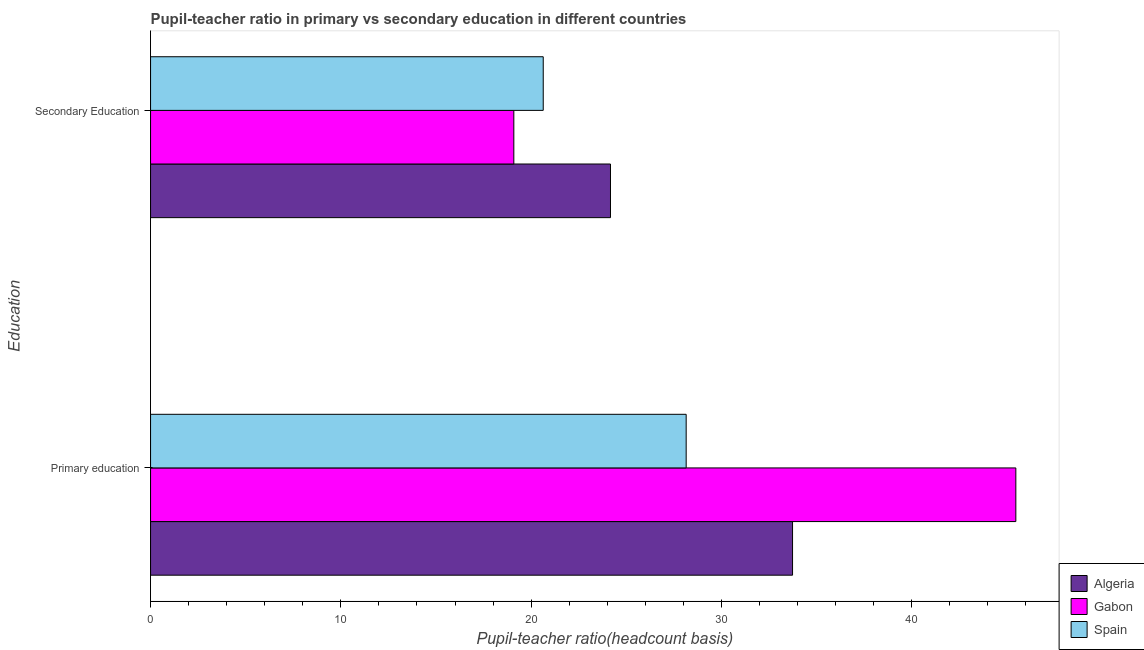How many different coloured bars are there?
Give a very brief answer. 3. What is the label of the 2nd group of bars from the top?
Ensure brevity in your answer.  Primary education. What is the pupil-teacher ratio in primary education in Spain?
Provide a short and direct response. 28.15. Across all countries, what is the maximum pupil-teacher ratio in primary education?
Make the answer very short. 45.48. Across all countries, what is the minimum pupil-teacher ratio in primary education?
Your response must be concise. 28.15. In which country was the pupil-teacher ratio in primary education maximum?
Your answer should be compact. Gabon. What is the total pupil-teacher ratio in primary education in the graph?
Provide a short and direct response. 107.37. What is the difference between the pupil-teacher ratio in primary education in Spain and that in Gabon?
Provide a short and direct response. -17.33. What is the difference between the pupil-teacher ratio in primary education in Algeria and the pupil teacher ratio on secondary education in Spain?
Provide a short and direct response. 13.1. What is the average pupil teacher ratio on secondary education per country?
Keep it short and to the point. 21.3. What is the difference between the pupil teacher ratio on secondary education and pupil-teacher ratio in primary education in Gabon?
Provide a succinct answer. -26.38. In how many countries, is the pupil-teacher ratio in primary education greater than 12 ?
Ensure brevity in your answer.  3. What is the ratio of the pupil-teacher ratio in primary education in Spain to that in Algeria?
Keep it short and to the point. 0.83. Is the pupil-teacher ratio in primary education in Algeria less than that in Gabon?
Offer a terse response. Yes. What does the 2nd bar from the top in Secondary Education represents?
Ensure brevity in your answer.  Gabon. What does the 2nd bar from the bottom in Primary education represents?
Your answer should be very brief. Gabon. Are all the bars in the graph horizontal?
Your answer should be compact. Yes. What is the difference between two consecutive major ticks on the X-axis?
Give a very brief answer. 10. Does the graph contain any zero values?
Ensure brevity in your answer.  No. Does the graph contain grids?
Provide a succinct answer. No. Where does the legend appear in the graph?
Offer a very short reply. Bottom right. What is the title of the graph?
Keep it short and to the point. Pupil-teacher ratio in primary vs secondary education in different countries. Does "Mongolia" appear as one of the legend labels in the graph?
Make the answer very short. No. What is the label or title of the X-axis?
Provide a short and direct response. Pupil-teacher ratio(headcount basis). What is the label or title of the Y-axis?
Ensure brevity in your answer.  Education. What is the Pupil-teacher ratio(headcount basis) in Algeria in Primary education?
Give a very brief answer. 33.74. What is the Pupil-teacher ratio(headcount basis) in Gabon in Primary education?
Provide a succinct answer. 45.48. What is the Pupil-teacher ratio(headcount basis) of Spain in Primary education?
Your answer should be compact. 28.15. What is the Pupil-teacher ratio(headcount basis) in Algeria in Secondary Education?
Give a very brief answer. 24.17. What is the Pupil-teacher ratio(headcount basis) in Gabon in Secondary Education?
Make the answer very short. 19.09. What is the Pupil-teacher ratio(headcount basis) in Spain in Secondary Education?
Make the answer very short. 20.64. Across all Education, what is the maximum Pupil-teacher ratio(headcount basis) of Algeria?
Ensure brevity in your answer.  33.74. Across all Education, what is the maximum Pupil-teacher ratio(headcount basis) in Gabon?
Your response must be concise. 45.48. Across all Education, what is the maximum Pupil-teacher ratio(headcount basis) of Spain?
Your response must be concise. 28.15. Across all Education, what is the minimum Pupil-teacher ratio(headcount basis) in Algeria?
Your answer should be compact. 24.17. Across all Education, what is the minimum Pupil-teacher ratio(headcount basis) of Gabon?
Ensure brevity in your answer.  19.09. Across all Education, what is the minimum Pupil-teacher ratio(headcount basis) in Spain?
Make the answer very short. 20.64. What is the total Pupil-teacher ratio(headcount basis) in Algeria in the graph?
Your response must be concise. 57.91. What is the total Pupil-teacher ratio(headcount basis) of Gabon in the graph?
Provide a short and direct response. 64.57. What is the total Pupil-teacher ratio(headcount basis) of Spain in the graph?
Offer a terse response. 48.79. What is the difference between the Pupil-teacher ratio(headcount basis) of Algeria in Primary education and that in Secondary Education?
Provide a succinct answer. 9.57. What is the difference between the Pupil-teacher ratio(headcount basis) in Gabon in Primary education and that in Secondary Education?
Make the answer very short. 26.38. What is the difference between the Pupil-teacher ratio(headcount basis) in Spain in Primary education and that in Secondary Education?
Offer a very short reply. 7.51. What is the difference between the Pupil-teacher ratio(headcount basis) of Algeria in Primary education and the Pupil-teacher ratio(headcount basis) of Gabon in Secondary Education?
Offer a very short reply. 14.65. What is the difference between the Pupil-teacher ratio(headcount basis) of Algeria in Primary education and the Pupil-teacher ratio(headcount basis) of Spain in Secondary Education?
Make the answer very short. 13.1. What is the difference between the Pupil-teacher ratio(headcount basis) of Gabon in Primary education and the Pupil-teacher ratio(headcount basis) of Spain in Secondary Education?
Make the answer very short. 24.84. What is the average Pupil-teacher ratio(headcount basis) in Algeria per Education?
Ensure brevity in your answer.  28.96. What is the average Pupil-teacher ratio(headcount basis) in Gabon per Education?
Provide a short and direct response. 32.28. What is the average Pupil-teacher ratio(headcount basis) of Spain per Education?
Provide a short and direct response. 24.39. What is the difference between the Pupil-teacher ratio(headcount basis) in Algeria and Pupil-teacher ratio(headcount basis) in Gabon in Primary education?
Give a very brief answer. -11.74. What is the difference between the Pupil-teacher ratio(headcount basis) of Algeria and Pupil-teacher ratio(headcount basis) of Spain in Primary education?
Your answer should be very brief. 5.59. What is the difference between the Pupil-teacher ratio(headcount basis) of Gabon and Pupil-teacher ratio(headcount basis) of Spain in Primary education?
Your response must be concise. 17.33. What is the difference between the Pupil-teacher ratio(headcount basis) in Algeria and Pupil-teacher ratio(headcount basis) in Gabon in Secondary Education?
Provide a short and direct response. 5.08. What is the difference between the Pupil-teacher ratio(headcount basis) in Algeria and Pupil-teacher ratio(headcount basis) in Spain in Secondary Education?
Provide a succinct answer. 3.53. What is the difference between the Pupil-teacher ratio(headcount basis) in Gabon and Pupil-teacher ratio(headcount basis) in Spain in Secondary Education?
Offer a terse response. -1.55. What is the ratio of the Pupil-teacher ratio(headcount basis) of Algeria in Primary education to that in Secondary Education?
Provide a succinct answer. 1.4. What is the ratio of the Pupil-teacher ratio(headcount basis) of Gabon in Primary education to that in Secondary Education?
Your answer should be very brief. 2.38. What is the ratio of the Pupil-teacher ratio(headcount basis) in Spain in Primary education to that in Secondary Education?
Keep it short and to the point. 1.36. What is the difference between the highest and the second highest Pupil-teacher ratio(headcount basis) of Algeria?
Ensure brevity in your answer.  9.57. What is the difference between the highest and the second highest Pupil-teacher ratio(headcount basis) of Gabon?
Provide a short and direct response. 26.38. What is the difference between the highest and the second highest Pupil-teacher ratio(headcount basis) of Spain?
Your answer should be compact. 7.51. What is the difference between the highest and the lowest Pupil-teacher ratio(headcount basis) in Algeria?
Your response must be concise. 9.57. What is the difference between the highest and the lowest Pupil-teacher ratio(headcount basis) of Gabon?
Make the answer very short. 26.38. What is the difference between the highest and the lowest Pupil-teacher ratio(headcount basis) of Spain?
Make the answer very short. 7.51. 